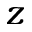<formula> <loc_0><loc_0><loc_500><loc_500>z</formula> 